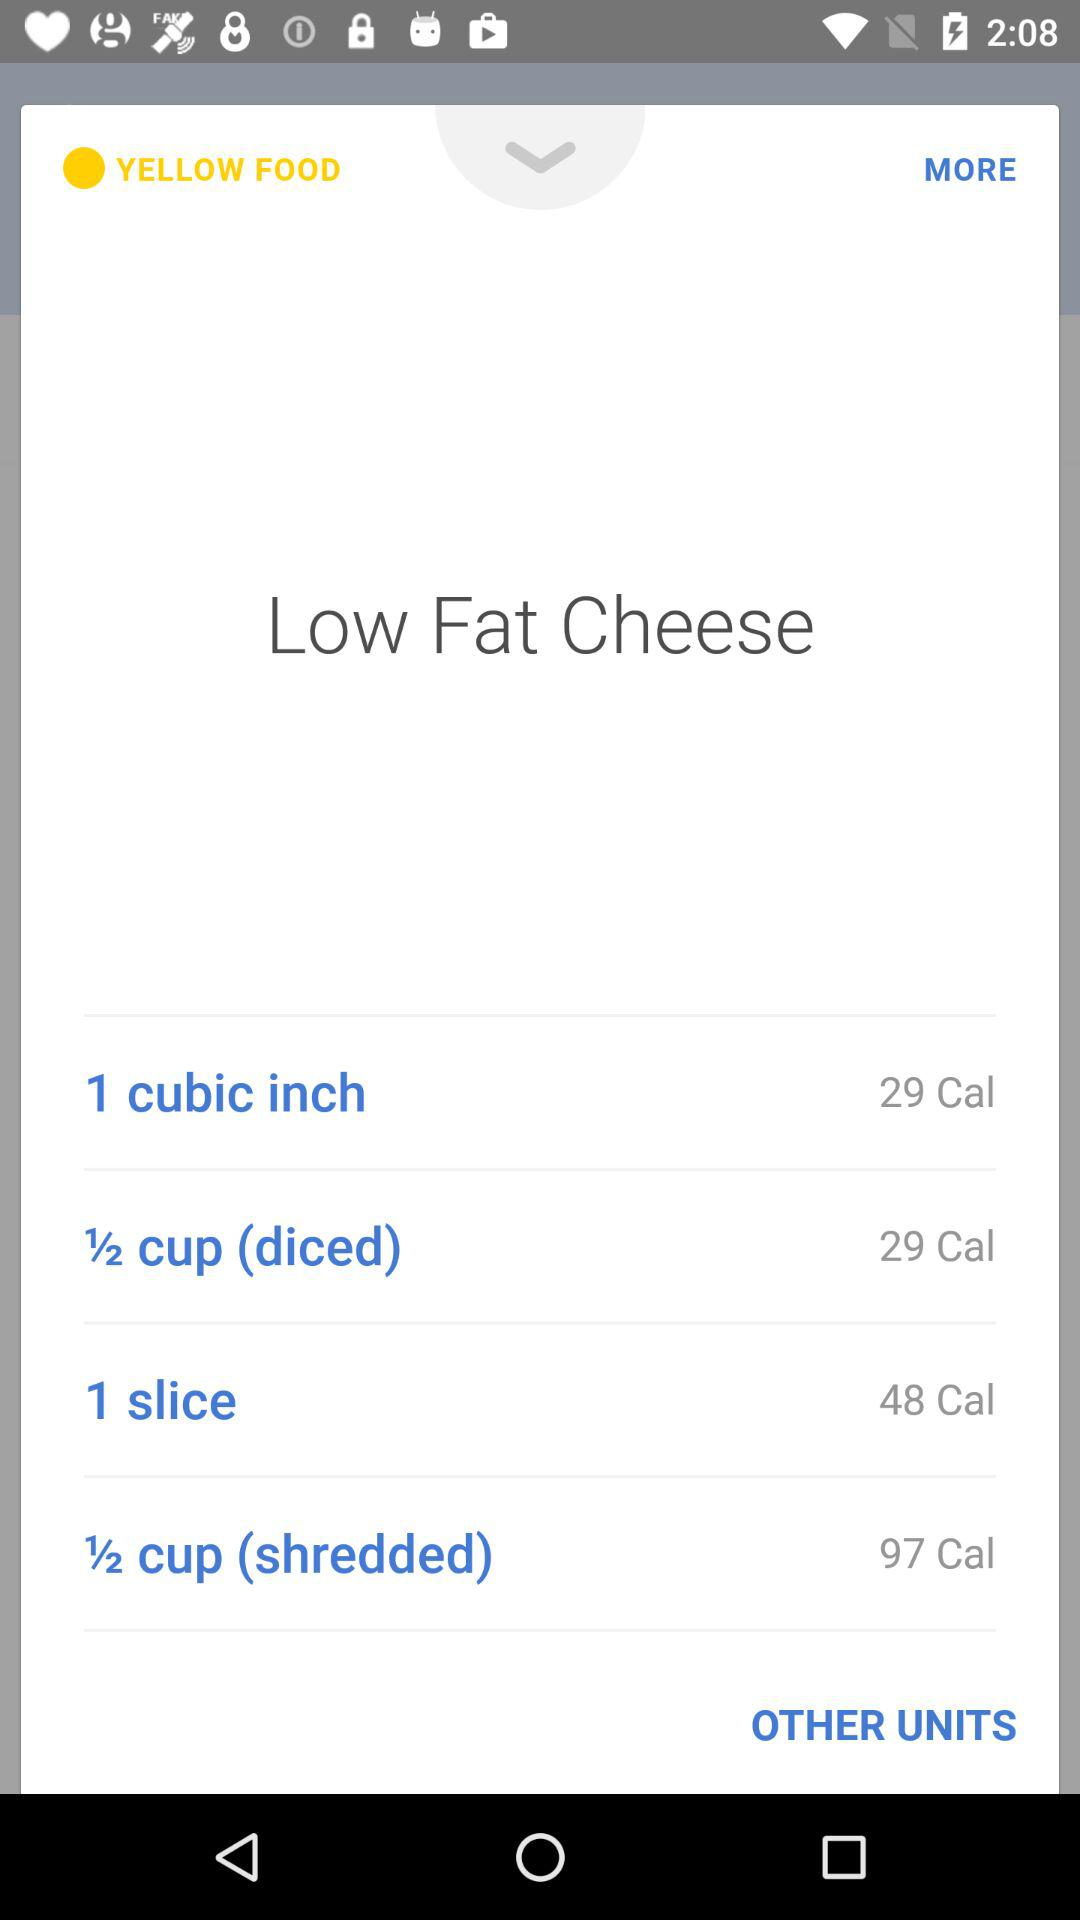How many calories are in a half cup (diced)? There are 29 calories in a half cup (diced). 